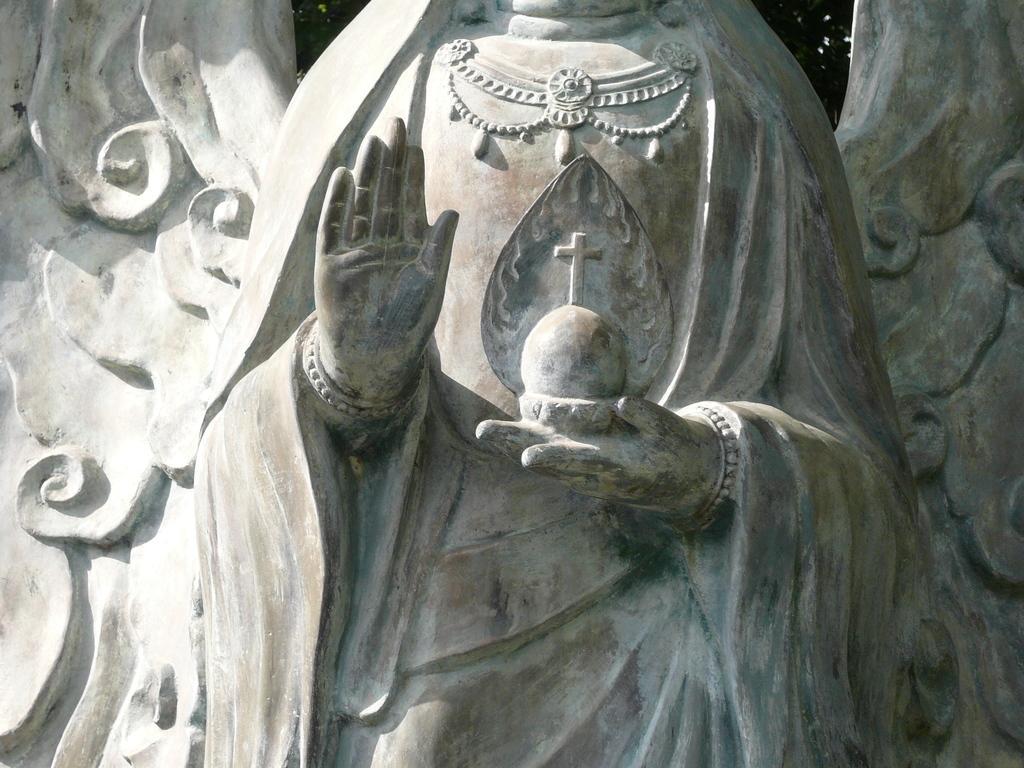Could you give a brief overview of what you see in this image? In this image there is a sculpture of a person as we can see in middle of this image. 